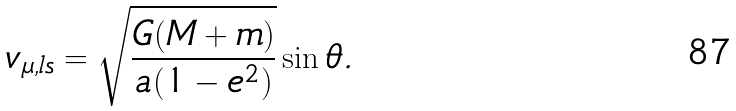Convert formula to latex. <formula><loc_0><loc_0><loc_500><loc_500>v _ { \mu , l s } = \sqrt { \frac { G ( M + m ) } { a ( 1 - e ^ { 2 } ) } } \sin \theta .</formula> 